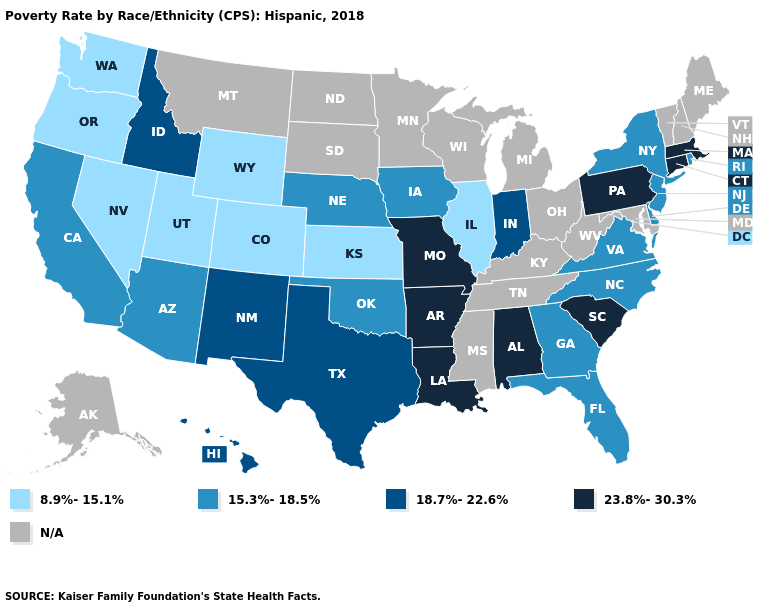Which states hav the highest value in the West?
Keep it brief. Hawaii, Idaho, New Mexico. Name the states that have a value in the range 8.9%-15.1%?
Write a very short answer. Colorado, Illinois, Kansas, Nevada, Oregon, Utah, Washington, Wyoming. Does Illinois have the lowest value in the MidWest?
Be succinct. Yes. Does Massachusetts have the highest value in the USA?
Be succinct. Yes. Among the states that border Washington , which have the highest value?
Answer briefly. Idaho. Name the states that have a value in the range 18.7%-22.6%?
Quick response, please. Hawaii, Idaho, Indiana, New Mexico, Texas. Name the states that have a value in the range 8.9%-15.1%?
Give a very brief answer. Colorado, Illinois, Kansas, Nevada, Oregon, Utah, Washington, Wyoming. What is the value of North Dakota?
Answer briefly. N/A. Which states have the lowest value in the South?
Keep it brief. Delaware, Florida, Georgia, North Carolina, Oklahoma, Virginia. Which states have the lowest value in the USA?
Keep it brief. Colorado, Illinois, Kansas, Nevada, Oregon, Utah, Washington, Wyoming. What is the highest value in states that border Vermont?
Keep it brief. 23.8%-30.3%. What is the value of Nebraska?
Keep it brief. 15.3%-18.5%. What is the lowest value in the USA?
Answer briefly. 8.9%-15.1%. 